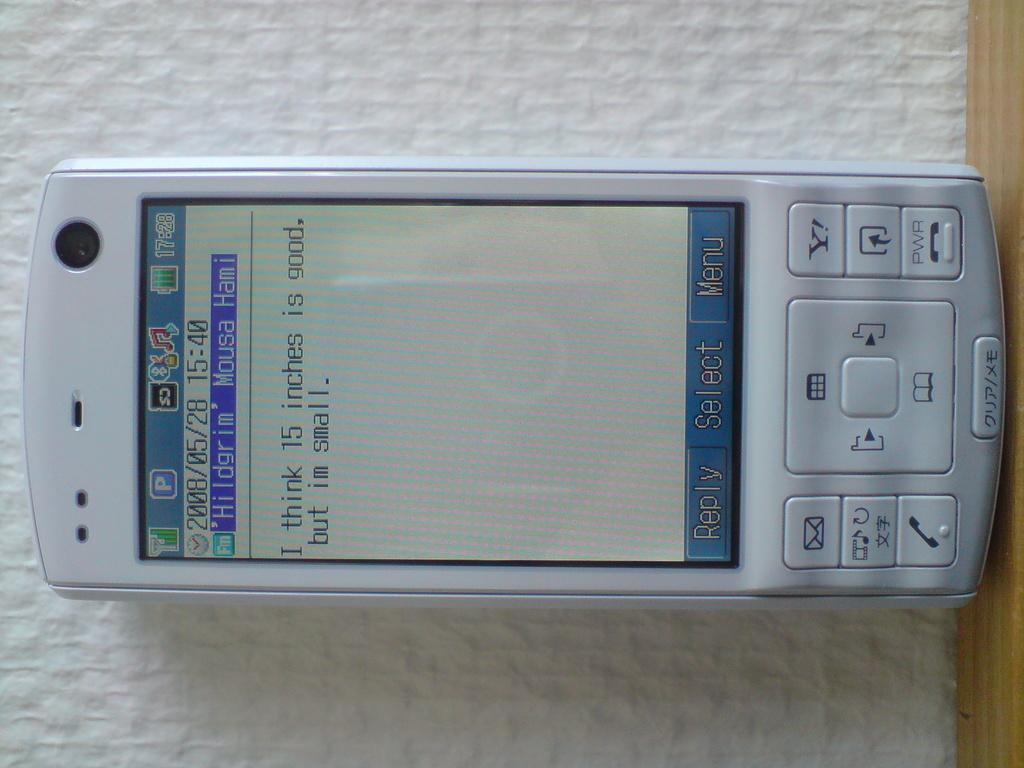<image>
Create a compact narrative representing the image presented. A text message response stating that 15 inches is good for the responder. 